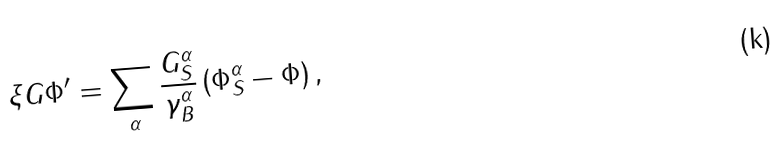Convert formula to latex. <formula><loc_0><loc_0><loc_500><loc_500>\xi G \Phi ^ { \prime } = \sum _ { \alpha } \frac { G _ { S } ^ { \alpha } } { \gamma _ { B } ^ { \alpha } } \left ( \Phi _ { S } ^ { \alpha } - \Phi \right ) ,</formula> 